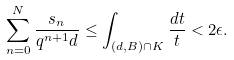Convert formula to latex. <formula><loc_0><loc_0><loc_500><loc_500>\sum _ { n = 0 } ^ { N } \frac { s _ { n } } { q ^ { n + 1 } d } \leq \int _ { ( d , B ) \cap K } \frac { d t } { t } < 2 \epsilon .</formula> 